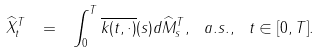Convert formula to latex. <formula><loc_0><loc_0><loc_500><loc_500>\widehat { X } ^ { T } _ { t } \ = \ \int ^ { T } _ { 0 } \overline { k ( t , \cdot ) } ( s ) d \widehat { M } ^ { T } _ { s } , \ a . s . , \ t \in [ 0 , T ] .</formula> 